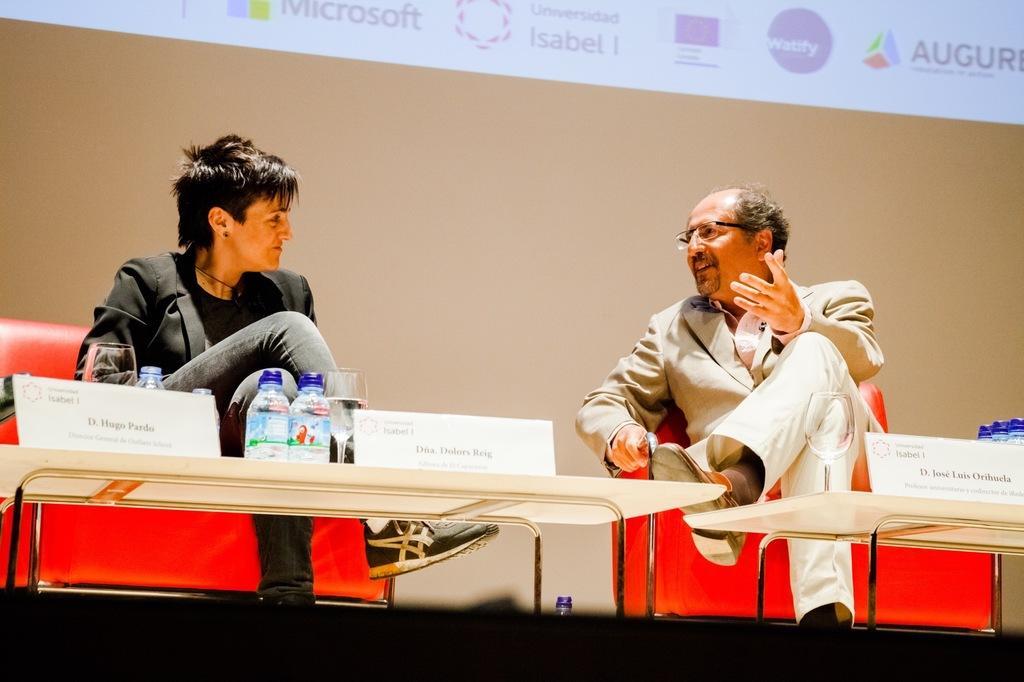Could you give a brief overview of what you see in this image? Here in this picture we can see a man and a woman sitting on chairs with table in front of them having bottles and glasses present and we can see both of them are talking to each other and the man is wearing spectacles and behind them we can see a projector screen with something projected on it and we can also see name cards present on the table. 